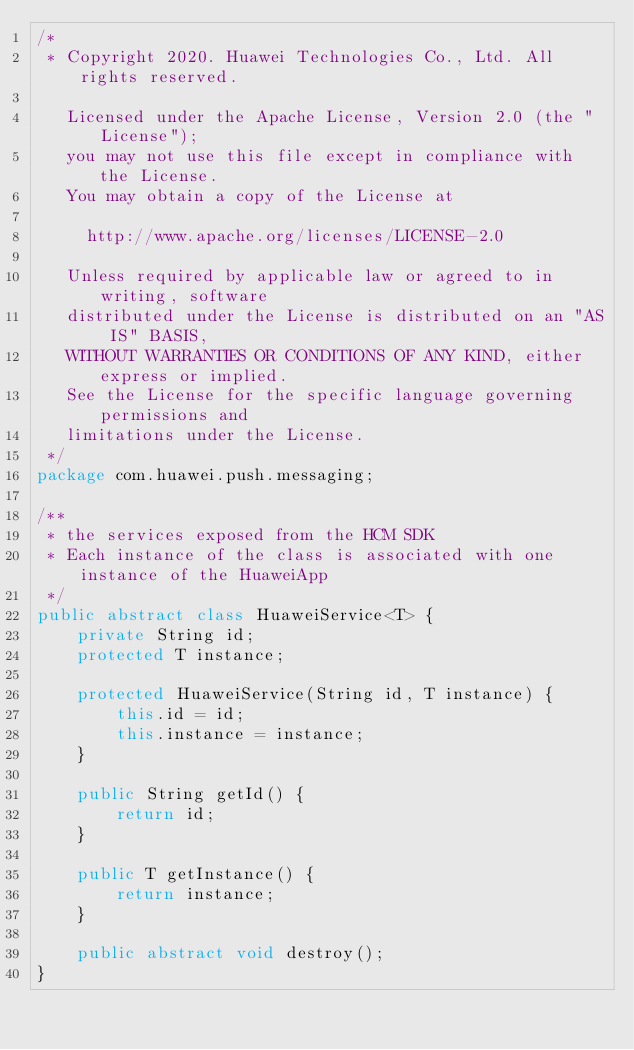<code> <loc_0><loc_0><loc_500><loc_500><_Java_>/*
 * Copyright 2020. Huawei Technologies Co., Ltd. All rights reserved.

   Licensed under the Apache License, Version 2.0 (the "License");
   you may not use this file except in compliance with the License.
   You may obtain a copy of the License at

     http://www.apache.org/licenses/LICENSE-2.0

   Unless required by applicable law or agreed to in writing, software
   distributed under the License is distributed on an "AS IS" BASIS,
   WITHOUT WARRANTIES OR CONDITIONS OF ANY KIND, either express or implied.
   See the License for the specific language governing permissions and
   limitations under the License.
 */
package com.huawei.push.messaging;

/**
 * the services exposed from the HCM SDK
 * Each instance of the class is associated with one instance of the HuaweiApp
 */
public abstract class HuaweiService<T> {
    private String id;
    protected T instance;

    protected HuaweiService(String id, T instance) {
        this.id = id;
        this.instance = instance;
    }

    public String getId() {
        return id;
    }

    public T getInstance() {
        return instance;
    }

    public abstract void destroy();
}
</code> 